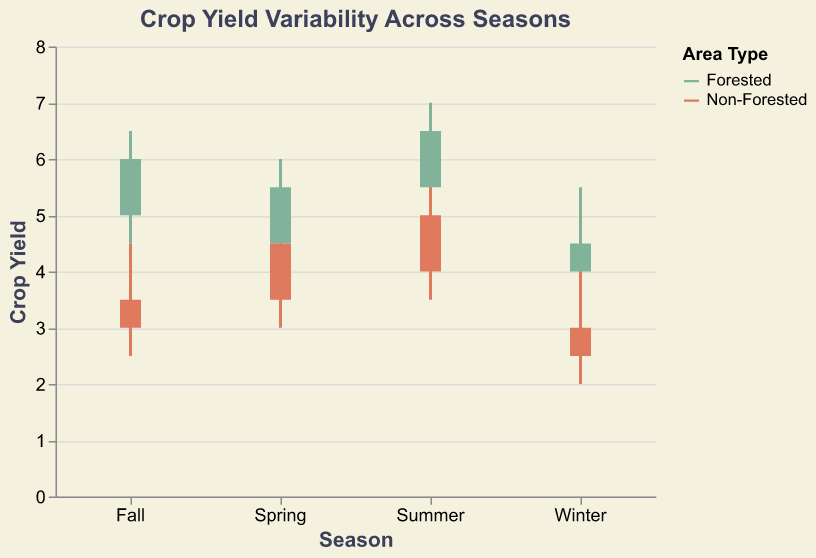What is the title of the figure? The title of the figure is typically displayed at the top of the plot. In this case, it is "Crop Yield Variability Across Seasons".
Answer: Crop Yield Variability Across Seasons What are the areas compared in the figure? The areas being compared are shown in different colors, as indicated by the legend. The two areas are "Forested" and "Non-Forested".
Answer: Forested and Non-Forested What is the maximum crop yield value in non-forested areas during the Winter? By looking at the candlestick and bar, the topmost point on the vertical line for Winter in the Non-Forested area gives the maximum value, which is 4.0.
Answer: 4.0 Which season shows the highest difference between high and low crop yields in forested areas? By comparing the height of the vertical lines (High - Low) for each season in forested areas, we find the largest difference is in Summer (7.0 - 5.0 = 2.0).
Answer: Summer During which season do non-forested areas have the lowest close value, and what is that value? By examining the closing values for all seasons in non-forested areas, the lowest closing value is in Winter and it is 3.0.
Answer: Winter, 3.0 How does the crop yield range in forested areas for Spring compare to that in non-forested areas for Spring? The range is calculated as High - Low. For forested areas in Spring, it is (6.0 - 4.0 = 2.0), and for non-forested areas in Spring, it is (5.0 - 3.0 = 2.0). Both ranges are equal.
Answer: Equal Which area, forested or non-forested, shows a greater overall variation in crop yields during Summer? By comparing the total range (High - Low) for Summer in both areas, forested area range is (7.0 - 5.0 = 2.0) and non-forested area range is (5.5 - 3.5 = 2.0). Both have the same variation.
Answer: Both same 